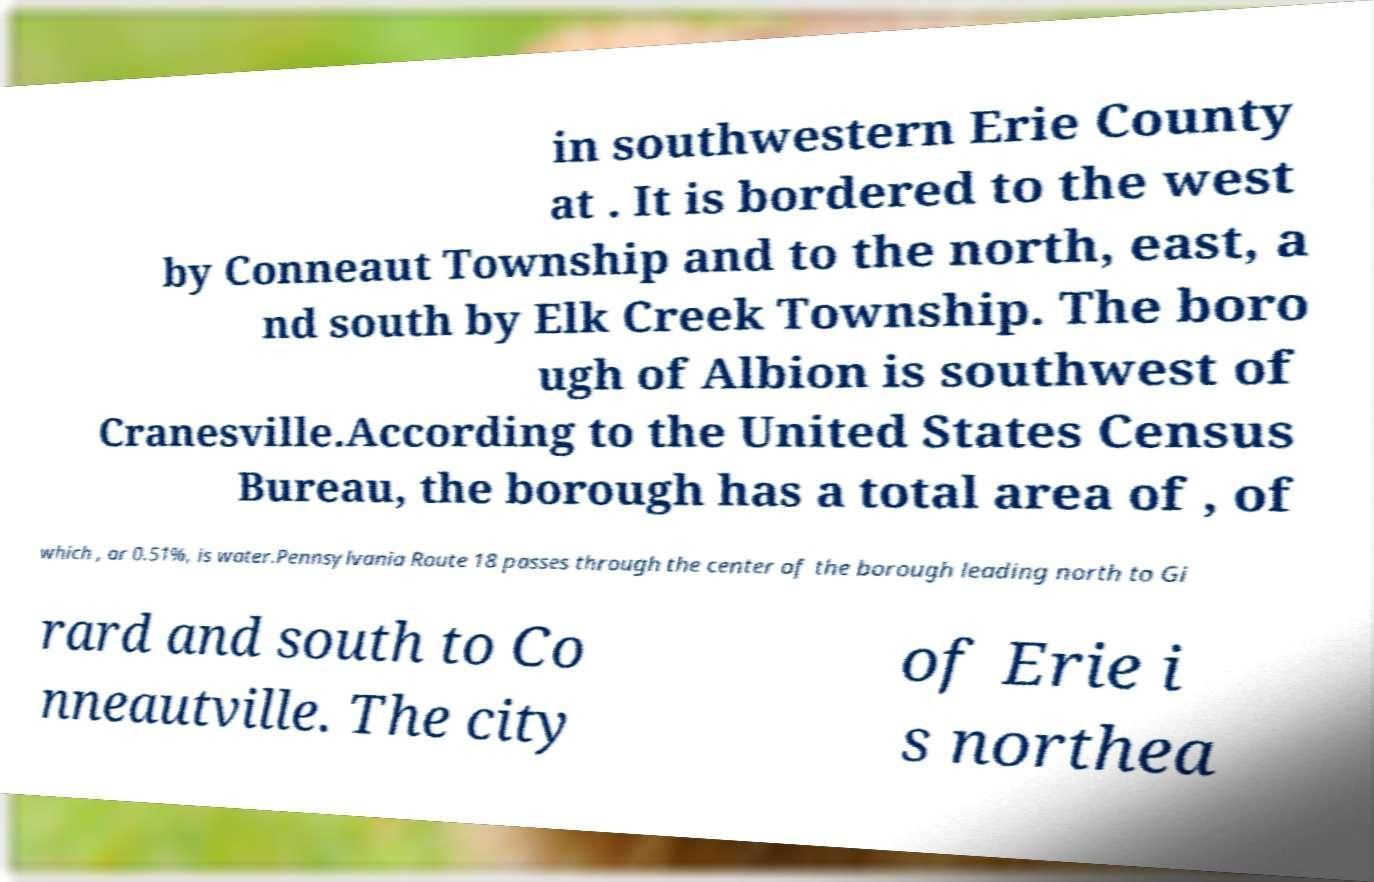For documentation purposes, I need the text within this image transcribed. Could you provide that? in southwestern Erie County at . It is bordered to the west by Conneaut Township and to the north, east, a nd south by Elk Creek Township. The boro ugh of Albion is southwest of Cranesville.According to the United States Census Bureau, the borough has a total area of , of which , or 0.51%, is water.Pennsylvania Route 18 passes through the center of the borough leading north to Gi rard and south to Co nneautville. The city of Erie i s northea 